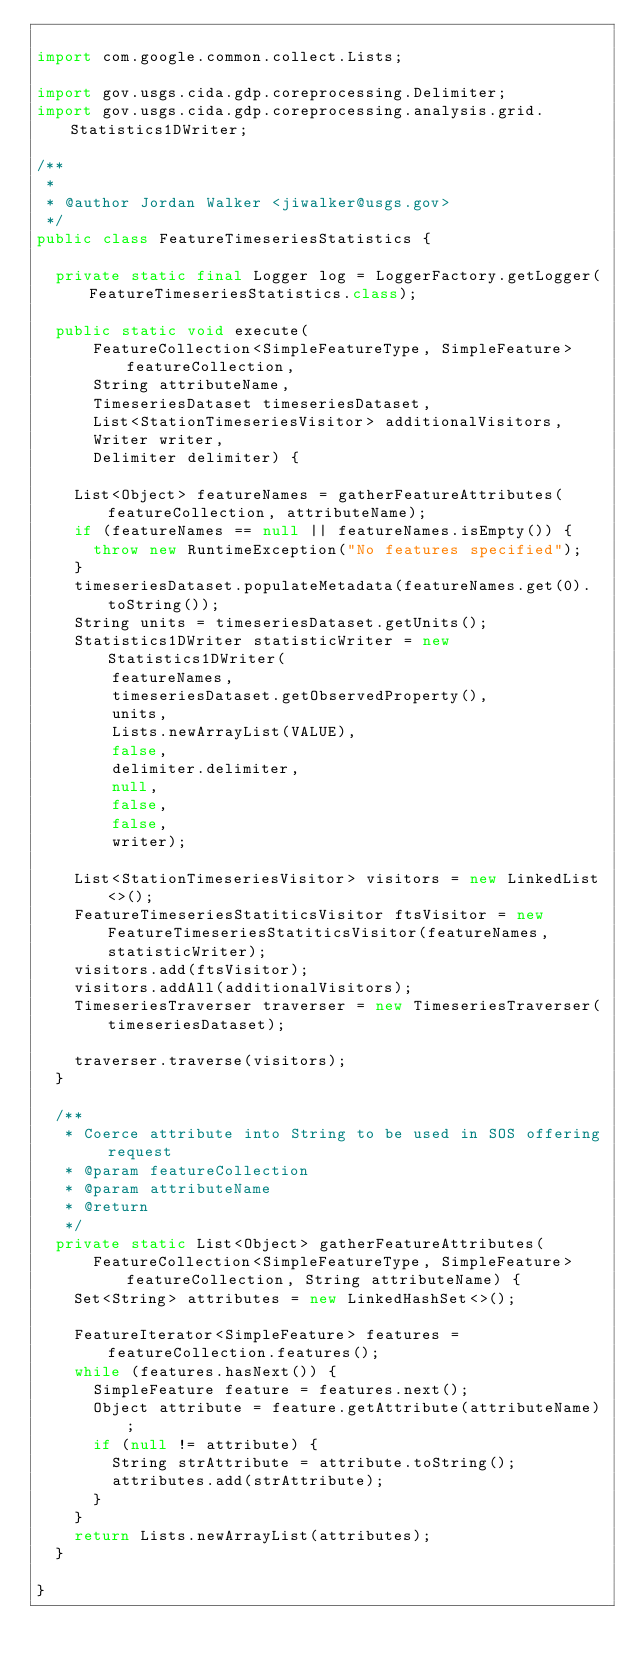<code> <loc_0><loc_0><loc_500><loc_500><_Java_>
import com.google.common.collect.Lists;

import gov.usgs.cida.gdp.coreprocessing.Delimiter;
import gov.usgs.cida.gdp.coreprocessing.analysis.grid.Statistics1DWriter;

/**
 *
 * @author Jordan Walker <jiwalker@usgs.gov>
 */
public class FeatureTimeseriesStatistics {

	private static final Logger log = LoggerFactory.getLogger(FeatureTimeseriesStatistics.class);

	public static void execute(
			FeatureCollection<SimpleFeatureType, SimpleFeature> featureCollection,
			String attributeName,
			TimeseriesDataset timeseriesDataset,
			List<StationTimeseriesVisitor> additionalVisitors,
			Writer writer,
			Delimiter delimiter) {

		List<Object> featureNames = gatherFeatureAttributes(featureCollection, attributeName);
		if (featureNames == null || featureNames.isEmpty()) {
			throw new RuntimeException("No features specified");
		}
		timeseriesDataset.populateMetadata(featureNames.get(0).toString());
		String units = timeseriesDataset.getUnits();
		Statistics1DWriter statisticWriter = new Statistics1DWriter(
				featureNames,
				timeseriesDataset.getObservedProperty(),
				units,
				Lists.newArrayList(VALUE),
				false,
				delimiter.delimiter,
				null,
				false,
				false,
				writer);
		
		List<StationTimeseriesVisitor> visitors = new LinkedList<>();
		FeatureTimeseriesStatiticsVisitor ftsVisitor = new FeatureTimeseriesStatiticsVisitor(featureNames, statisticWriter);
		visitors.add(ftsVisitor);
		visitors.addAll(additionalVisitors);
		TimeseriesTraverser traverser = new TimeseriesTraverser(timeseriesDataset);
		
		traverser.traverse(visitors);
	}

	/**
	 * Coerce attribute into String to be used in SOS offering request
	 * @param featureCollection
	 * @param attributeName
	 * @return 
	 */
	private static List<Object> gatherFeatureAttributes(
			FeatureCollection<SimpleFeatureType, SimpleFeature> featureCollection, String attributeName) {
		Set<String> attributes = new LinkedHashSet<>();
		
		FeatureIterator<SimpleFeature> features = featureCollection.features();
		while (features.hasNext()) {
			SimpleFeature feature = features.next();
			Object attribute = feature.getAttribute(attributeName);
			if (null != attribute) {
				String strAttribute = attribute.toString();
				attributes.add(strAttribute);
			}
		}
		return Lists.newArrayList(attributes);
	}

}
</code> 